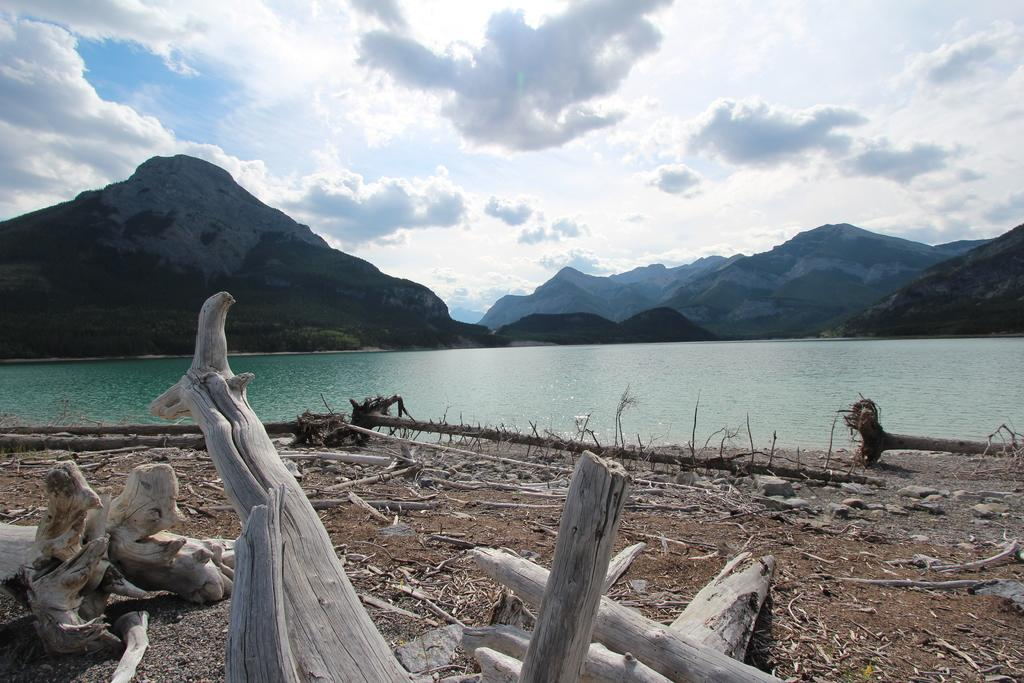What is on the surface in the image? There are wood logs on the surface in the image. What is in front of the wood logs? There is a river in front of the wood logs. What can be seen in the background of the image? There are mountains visible behind the river. What type of smile can be seen on the wood logs in the image? There is no smile present in the image, as wood logs are inanimate objects and cannot display emotions. 